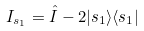<formula> <loc_0><loc_0><loc_500><loc_500>I _ { s _ { 1 } } = \hat { I } - 2 | s _ { 1 } \rangle \langle s _ { 1 } |</formula> 